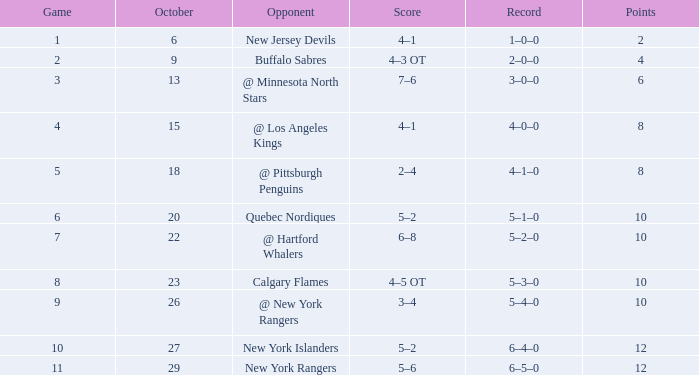In which october is there a record of 5-1-0 and a game that is larger than 6? None. 